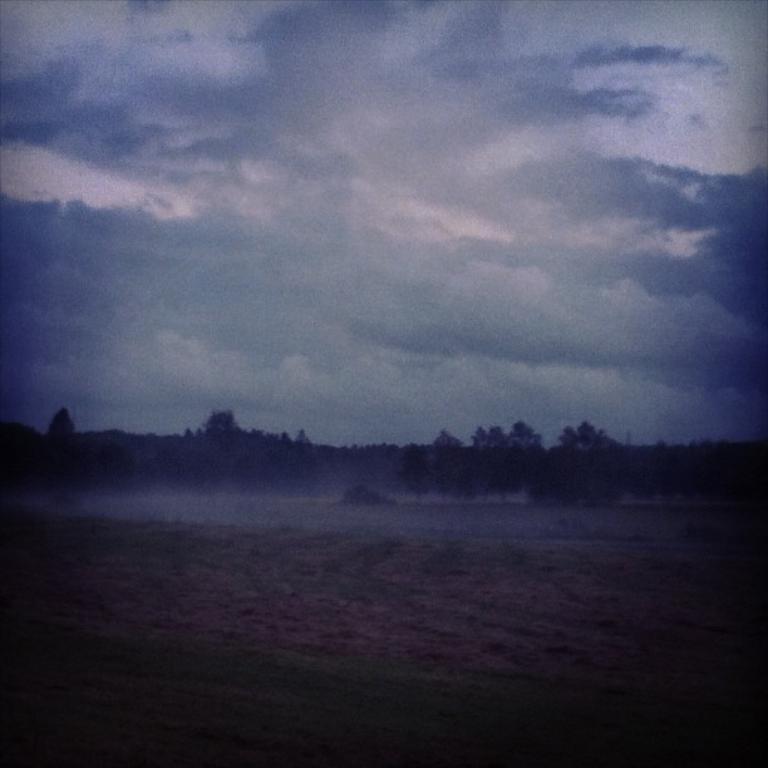Please provide a concise description of this image. In this image in the background there are trees. The sky is cloudy. The picture is blur. 